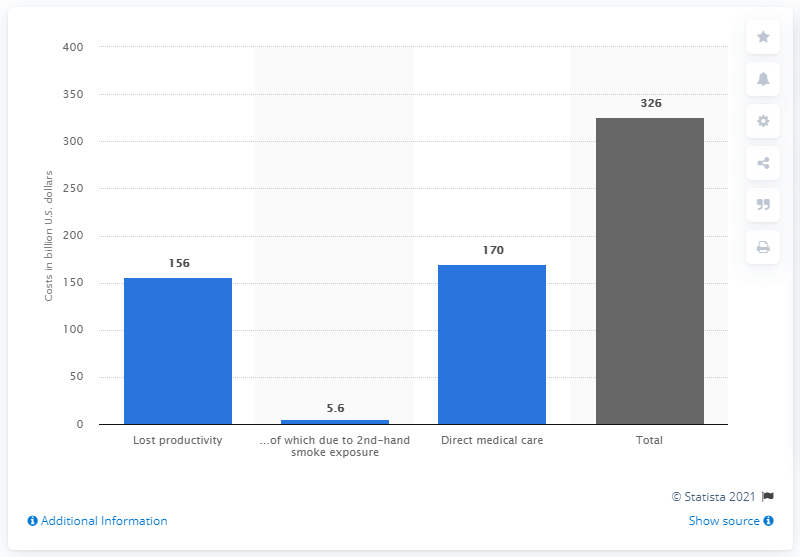Give some essential details in this illustration. The direct health care expenditures were approximately 170 million dollars. 